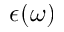Convert formula to latex. <formula><loc_0><loc_0><loc_500><loc_500>\epsilon ( \omega )</formula> 